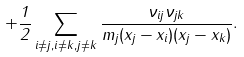Convert formula to latex. <formula><loc_0><loc_0><loc_500><loc_500>+ \frac { 1 } { 2 } \sum _ { i \neq j , i \neq k , j \neq k } \frac { { \nu } _ { i j } { \nu } _ { j k } } { m _ { j } ( x _ { j } - x _ { i } ) ( x _ { j } - x _ { k } ) } .</formula> 